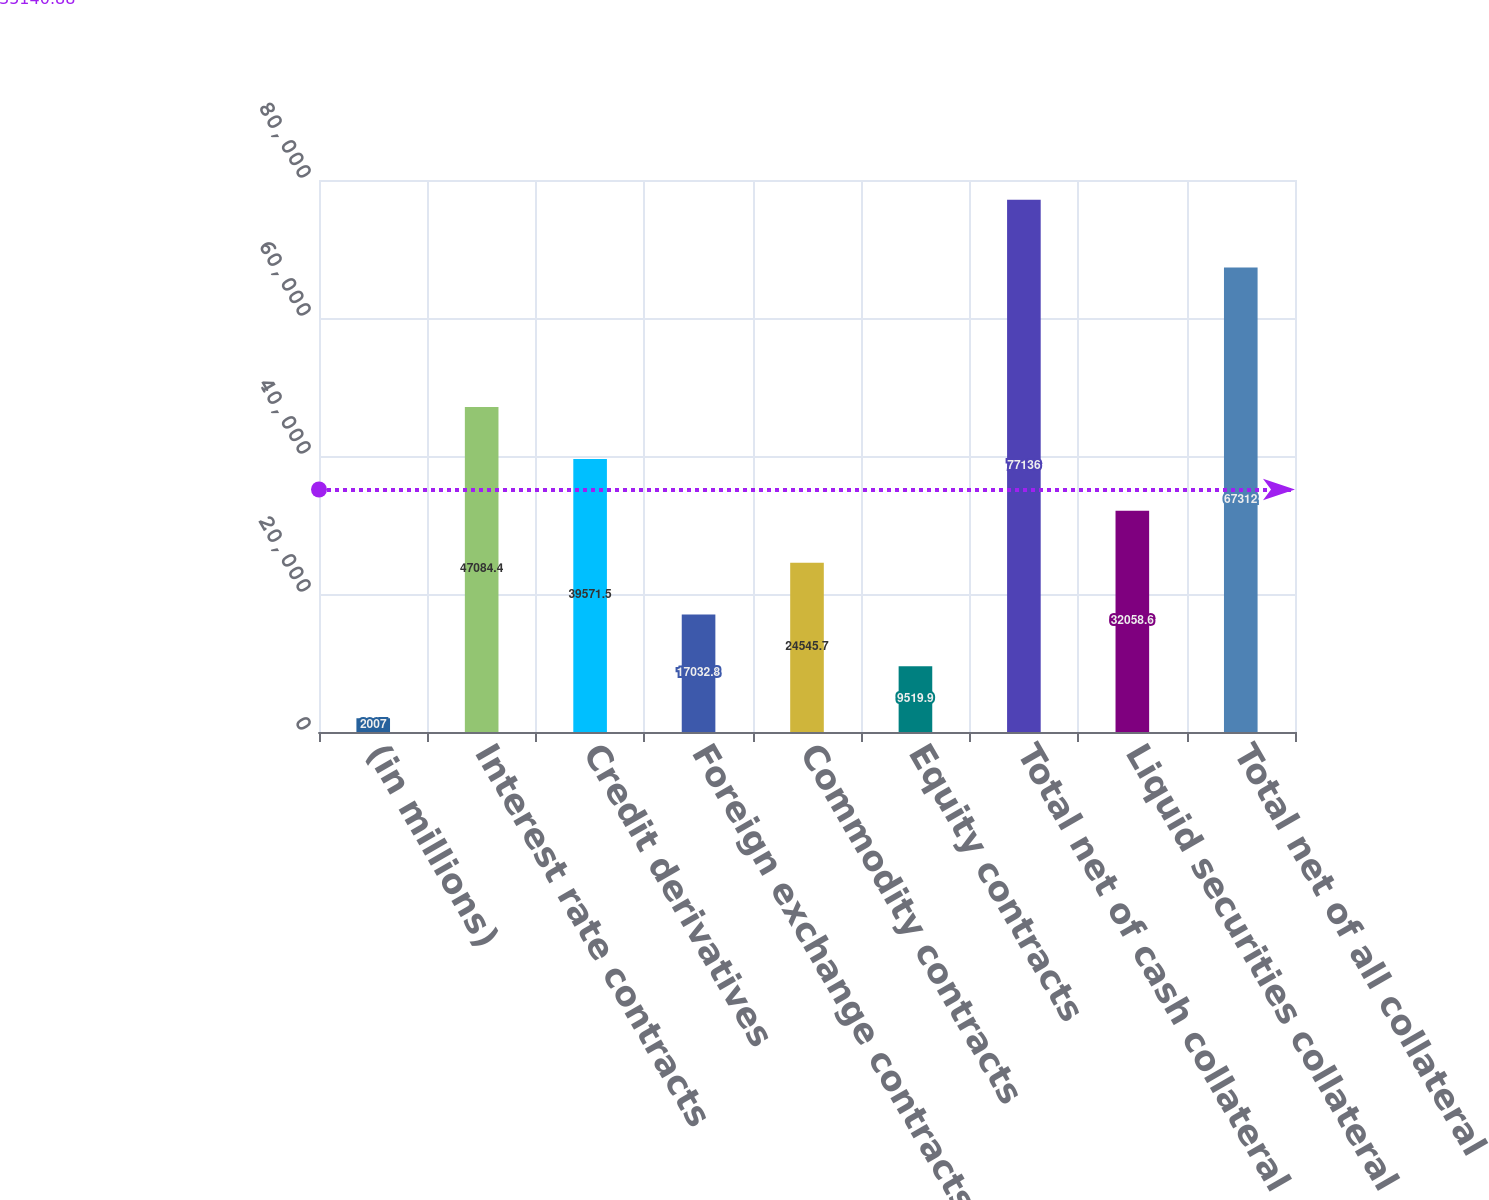Convert chart to OTSL. <chart><loc_0><loc_0><loc_500><loc_500><bar_chart><fcel>(in millions)<fcel>Interest rate contracts<fcel>Credit derivatives<fcel>Foreign exchange contracts<fcel>Commodity contracts<fcel>Equity contracts<fcel>Total net of cash collateral<fcel>Liquid securities collateral<fcel>Total net of all collateral<nl><fcel>2007<fcel>47084.4<fcel>39571.5<fcel>17032.8<fcel>24545.7<fcel>9519.9<fcel>77136<fcel>32058.6<fcel>67312<nl></chart> 